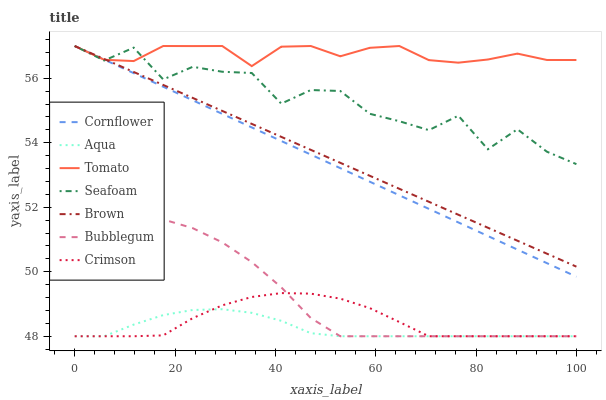Does Aqua have the minimum area under the curve?
Answer yes or no. Yes. Does Tomato have the maximum area under the curve?
Answer yes or no. Yes. Does Cornflower have the minimum area under the curve?
Answer yes or no. No. Does Cornflower have the maximum area under the curve?
Answer yes or no. No. Is Cornflower the smoothest?
Answer yes or no. Yes. Is Seafoam the roughest?
Answer yes or no. Yes. Is Brown the smoothest?
Answer yes or no. No. Is Brown the roughest?
Answer yes or no. No. Does Aqua have the lowest value?
Answer yes or no. Yes. Does Cornflower have the lowest value?
Answer yes or no. No. Does Seafoam have the highest value?
Answer yes or no. Yes. Does Aqua have the highest value?
Answer yes or no. No. Is Bubblegum less than Brown?
Answer yes or no. Yes. Is Cornflower greater than Crimson?
Answer yes or no. Yes. Does Brown intersect Tomato?
Answer yes or no. Yes. Is Brown less than Tomato?
Answer yes or no. No. Is Brown greater than Tomato?
Answer yes or no. No. Does Bubblegum intersect Brown?
Answer yes or no. No. 